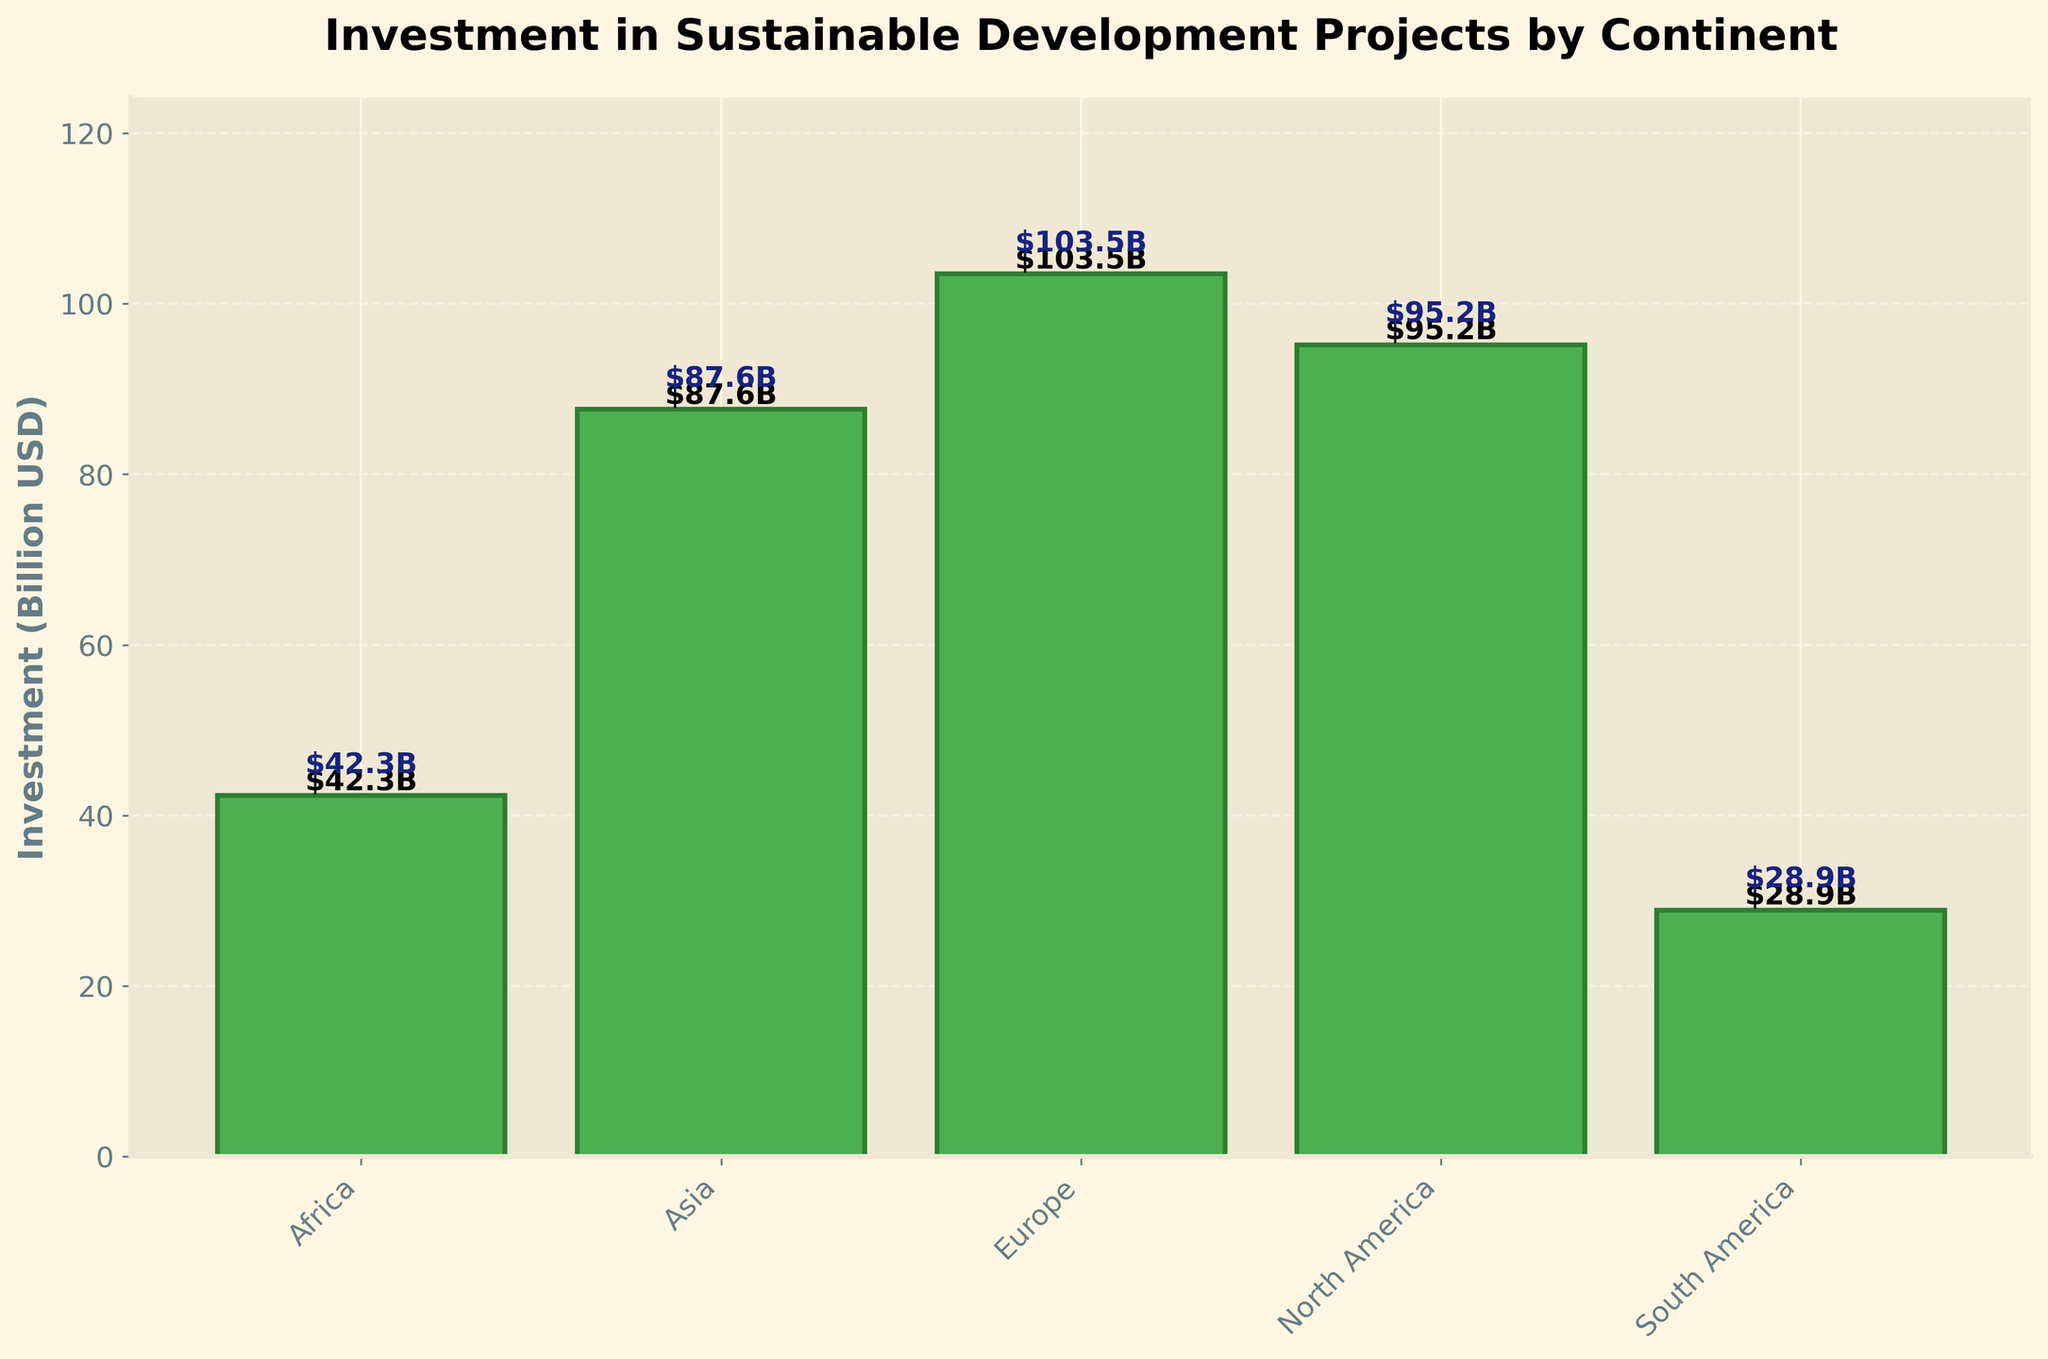What is the total investment in sustainable development projects across all continents? To get the total investment, sum the investments from all continents: $42.3B (Africa) + $87.6B (Asia) + $103.5B (Europe) + $95.2B (North America) + $28.9B (South America). This gives $357.5B
Answer: $357.5B Which continent has the highest investment in sustainable development projects? Looking at the heights of the bars, the bar for Europe is the tallest, indicating the highest investment amount of $103.5B
Answer: Europe How much more is invested in North America compared to South America? Subtract the investment in South America from the investment in North America: $95.2B - $28.9B = $66.3B
Answer: $66.3B What's the average investment in sustainable development projects across all continents? Sum of all investments is $357.5B and there are 5 continents. The average investment is $357.5B / 5 = $71.5B
Answer: $71.5B Which two continents have the closest investment amounts? Looking at the values: Africa ($42.3B), Asia ($87.6B), Europe ($103.5B), North America ($95.2B), South America ($28.9B), North America and Asia have investments close to each other. Difference is $95.2B - $87.6B = $7.6B
Answer: North America and Asia What is the combined investment in Africa and South America? Sum the investments for Africa and South America: $42.3B + $28.9B = $71.2B
Answer: $71.2B What is the difference between the highest and lowest investment amounts? Highest investment is in Europe ($103.5B) and lowest is in South America ($28.9B). Difference: $103.5B - $28.9B = $74.6B
Answer: $74.6B How many continents have an investment greater than $50 billion? By comparing each value, Africa ($42.3B) is less than $50B, but Asia ($87.6B), Europe ($103.5B), and North America ($95.2B) are greater. Therefore, 3 continents have investments greater than $50B
Answer: 3 